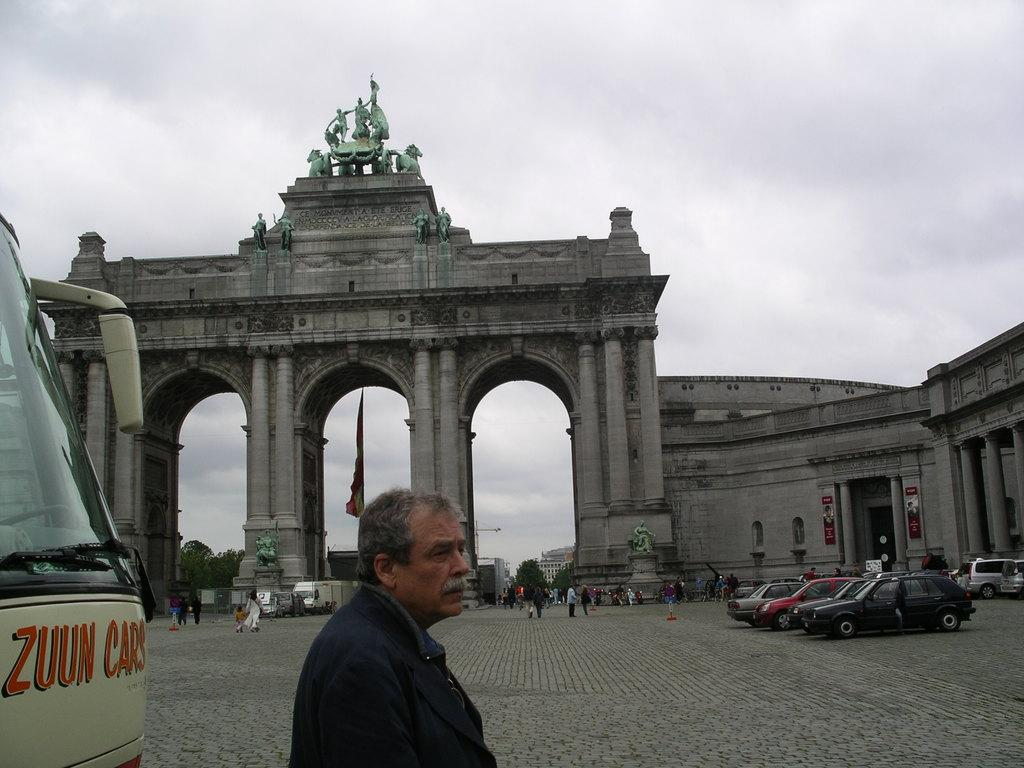What is the main subject of the image? There is a man standing in the image. What is located behind the man? There is a bus behind the man. What type of vehicles can be seen in the image? There are cars in the image. What type of structures are visible in the image? There is architecture visible in the image. What type of artistic objects can be seen in the image? There are statues in the image. What is the condition of the sky in the image? The sky is clear in the image. What type of honey is being rewarded to the statues in the image? There is no honey or reward being given to the statues in the image; they are simply present as part of the architecture. Is there a garden visible in the image? There is no garden present in the image. 